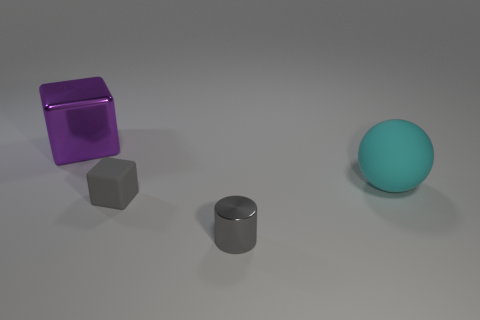What is the shape of the small thing that is the same color as the rubber block?
Offer a terse response. Cylinder. Does the cube that is in front of the cyan object have the same color as the shiny object that is in front of the cyan matte thing?
Offer a very short reply. Yes. Is the number of large matte things in front of the shiny cube greater than the number of brown metallic blocks?
Your answer should be very brief. Yes. What is the tiny gray block made of?
Provide a short and direct response. Rubber. There is a big thing that is made of the same material as the tiny block; what shape is it?
Give a very brief answer. Sphere. What size is the matte thing that is right of the metallic object that is to the right of the large purple block?
Your answer should be very brief. Large. What is the color of the shiny thing that is in front of the matte sphere?
Keep it short and to the point. Gray. Is there a large purple shiny object that has the same shape as the gray rubber object?
Provide a short and direct response. Yes. Is the number of large metal cubes that are in front of the cyan matte ball less than the number of gray things that are in front of the large purple metal block?
Your answer should be compact. Yes. What is the color of the big matte object?
Offer a very short reply. Cyan. 